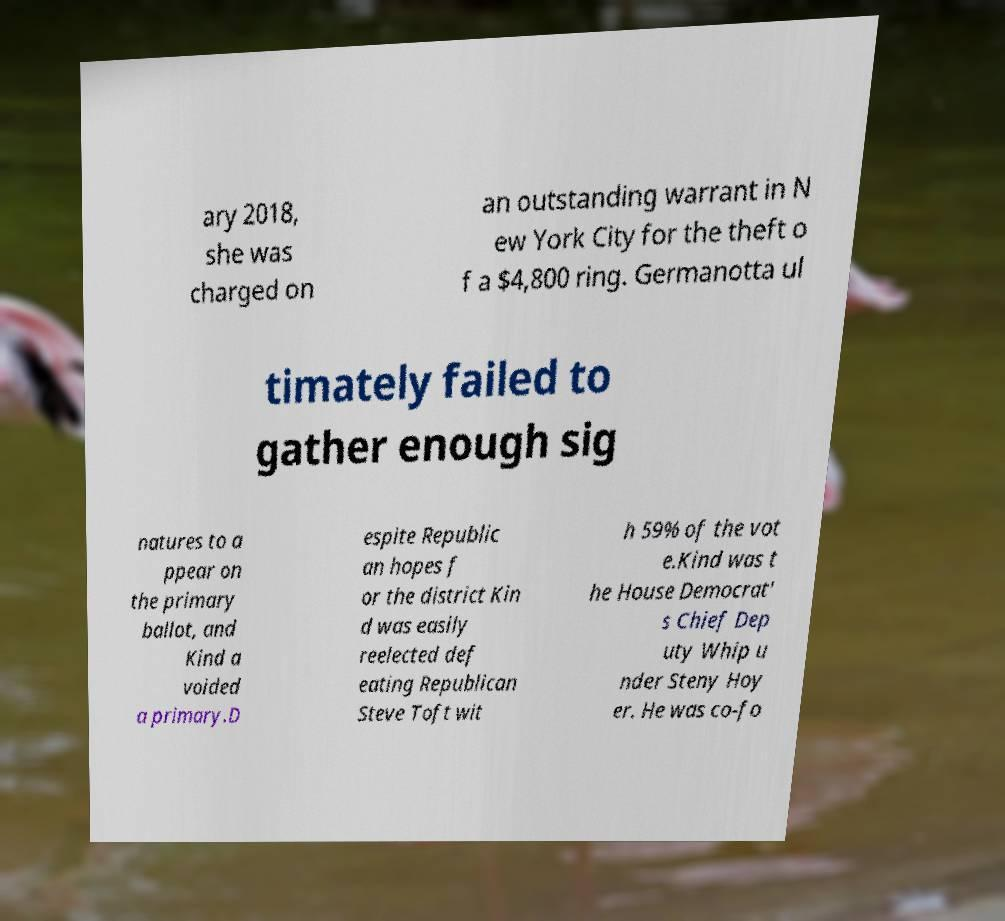I need the written content from this picture converted into text. Can you do that? ary 2018, she was charged on an outstanding warrant in N ew York City for the theft o f a $4,800 ring. Germanotta ul timately failed to gather enough sig natures to a ppear on the primary ballot, and Kind a voided a primary.D espite Republic an hopes f or the district Kin d was easily reelected def eating Republican Steve Toft wit h 59% of the vot e.Kind was t he House Democrat' s Chief Dep uty Whip u nder Steny Hoy er. He was co-fo 